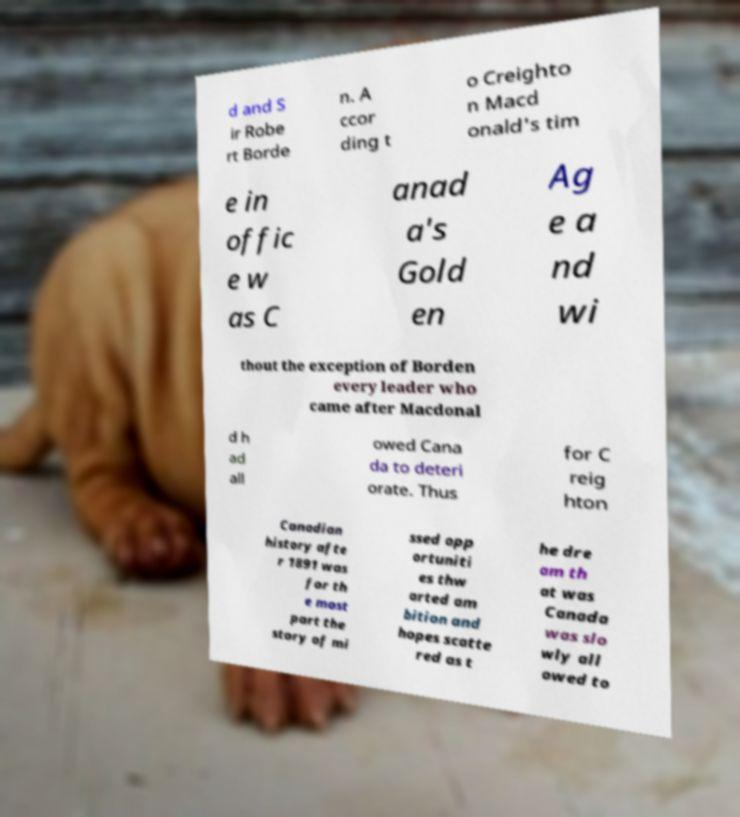Can you accurately transcribe the text from the provided image for me? d and S ir Robe rt Borde n. A ccor ding t o Creighto n Macd onald's tim e in offic e w as C anad a's Gold en Ag e a nd wi thout the exception of Borden every leader who came after Macdonal d h ad all owed Cana da to deteri orate. Thus for C reig hton Canadian history afte r 1891 was for th e most part the story of mi ssed opp ortuniti es thw arted am bition and hopes scatte red as t he dre am th at was Canada was slo wly all owed to 